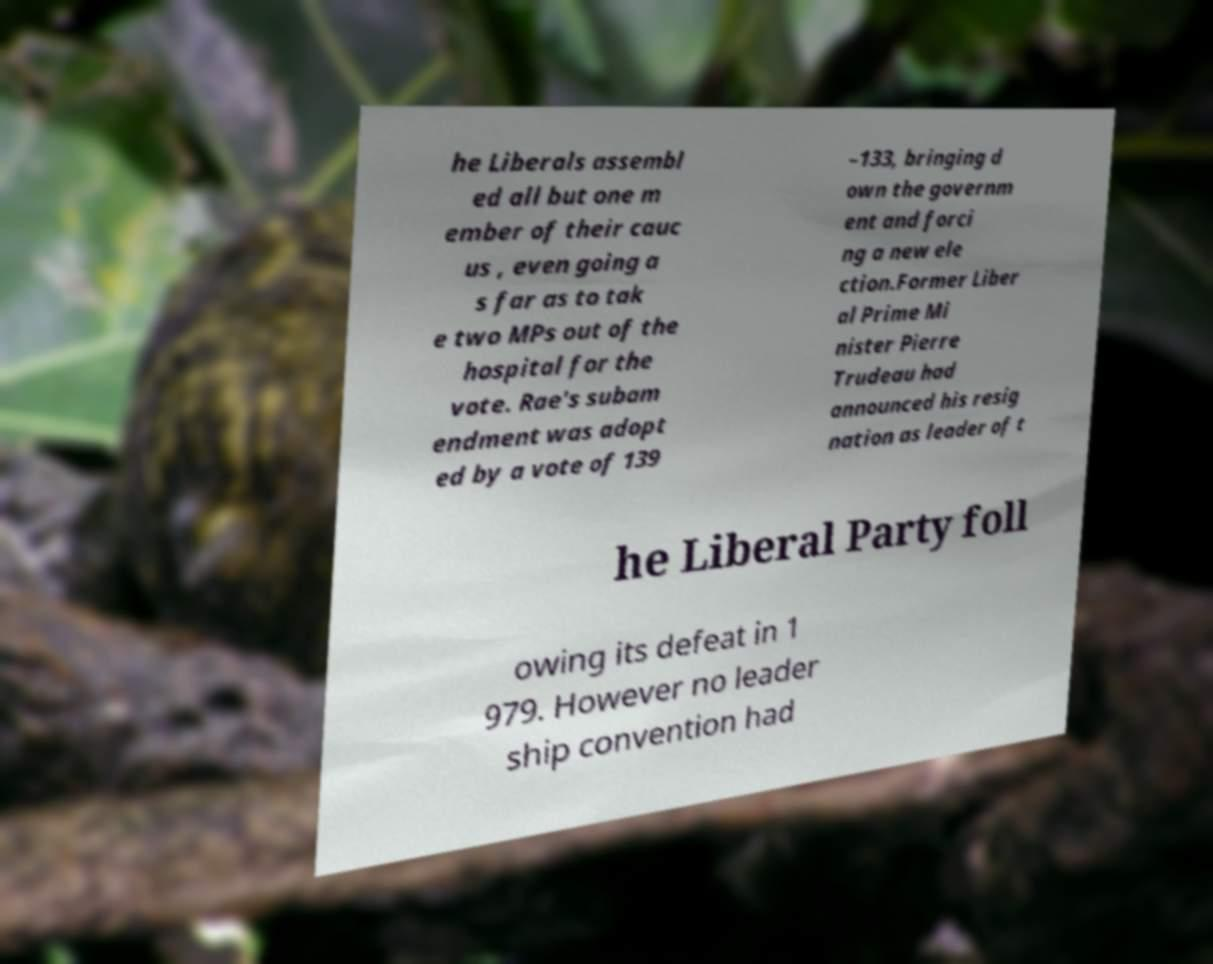For documentation purposes, I need the text within this image transcribed. Could you provide that? he Liberals assembl ed all but one m ember of their cauc us , even going a s far as to tak e two MPs out of the hospital for the vote. Rae's subam endment was adopt ed by a vote of 139 –133, bringing d own the governm ent and forci ng a new ele ction.Former Liber al Prime Mi nister Pierre Trudeau had announced his resig nation as leader of t he Liberal Party foll owing its defeat in 1 979. However no leader ship convention had 